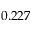Convert formula to latex. <formula><loc_0><loc_0><loc_500><loc_500>0 . 2 2 7</formula> 